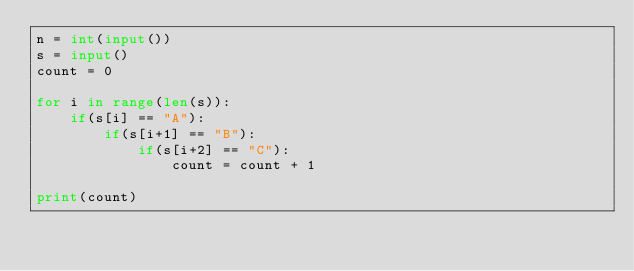<code> <loc_0><loc_0><loc_500><loc_500><_Python_>n = int(input())
s = input()
count = 0

for i in range(len(s)):
    if(s[i] == "A"):
        if(s[i+1] == "B"):
            if(s[i+2] == "C"):
                count = count + 1

print(count)
</code> 